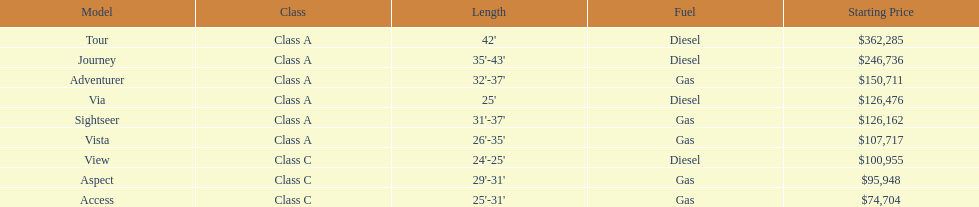What is the total number of class a models? 6. 